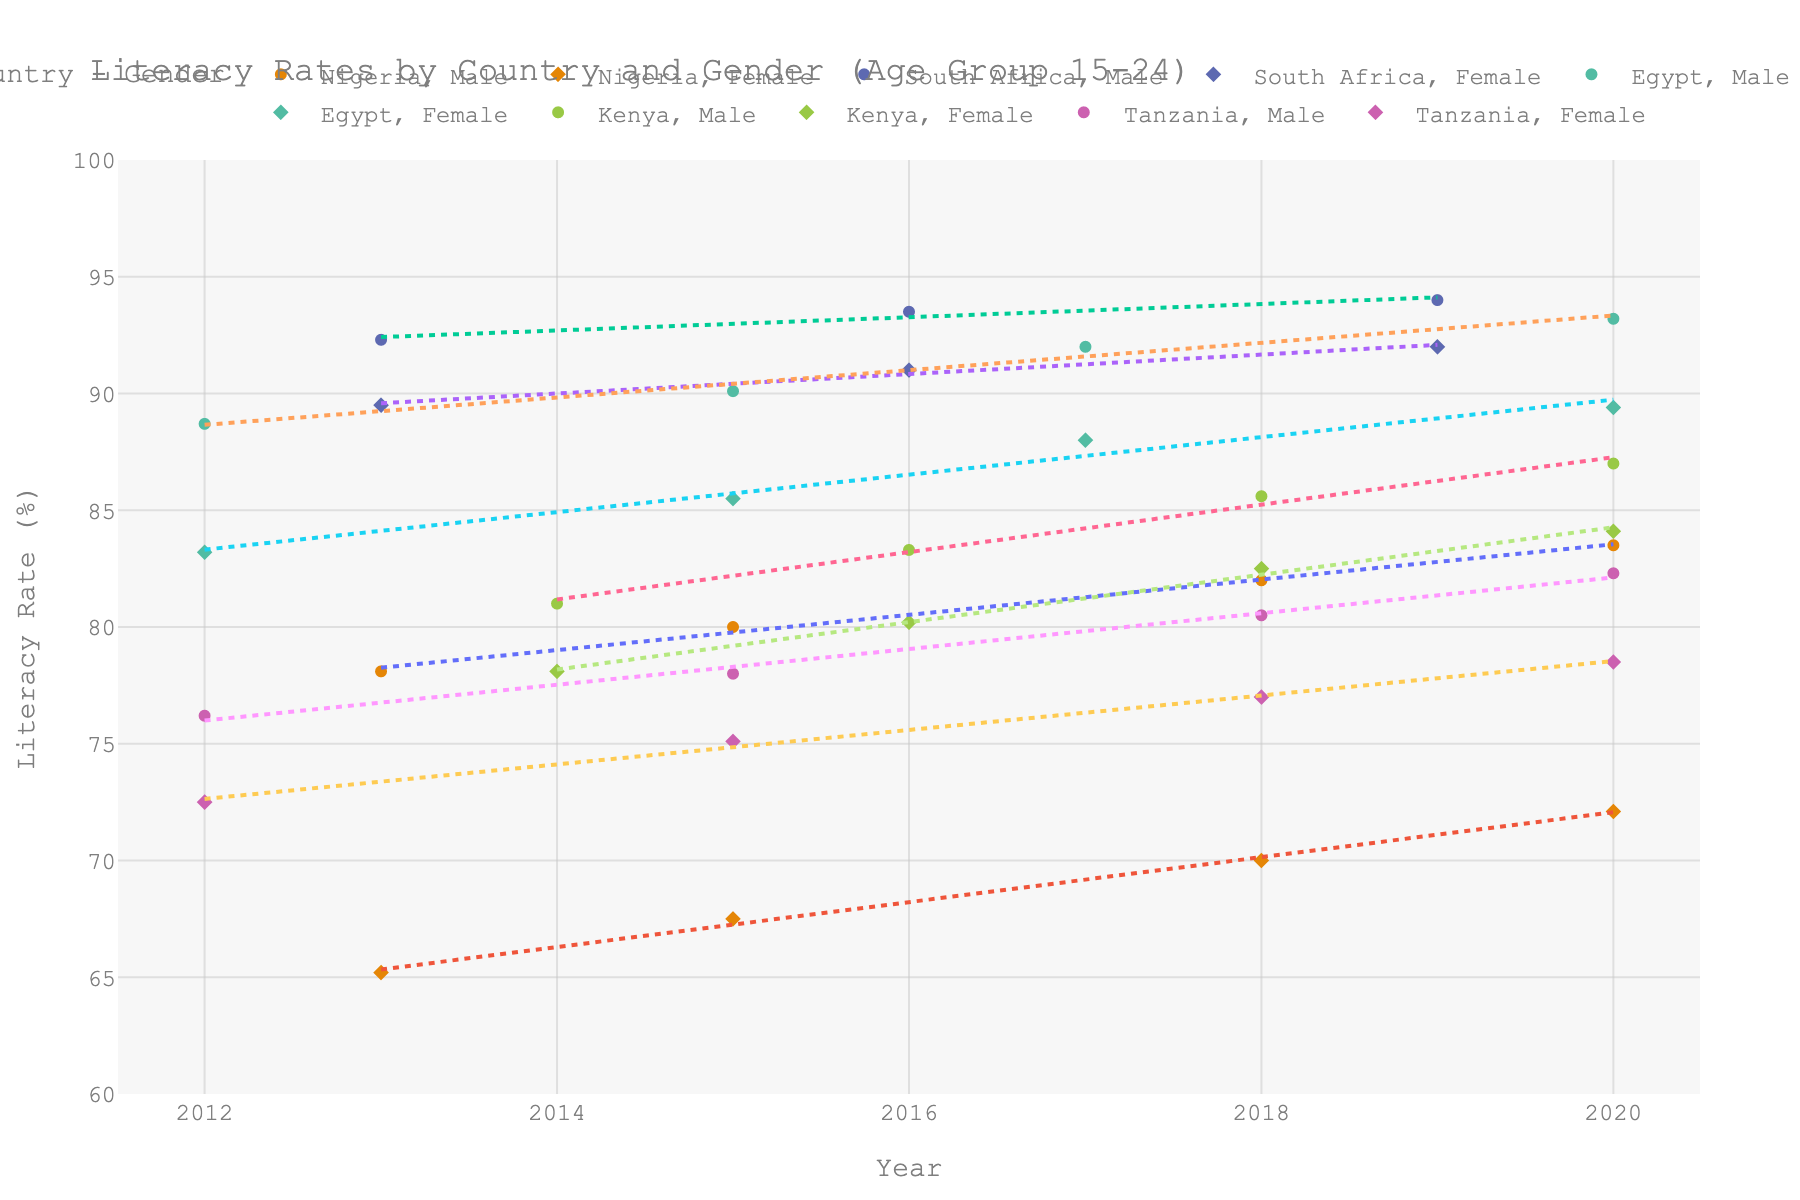What is the title of the figure? The title can typically be found at the top of the figure. Here, it likely summarizes the main theme of the data visualization.
Answer: Literacy Rates by Country and Gender (Age Group 15-24) Which country has the highest male literacy rate overall? To determine this, observe the data points for each country and compare the highest male literacy rates visually.
Answer: South Africa Between 2018 and 2020, did the female literacy rate in Nigeria increase or decrease? Look at the trend line for Nigeria's female literacy rate from 2018 to 2020. Note whether the line slopes upward or downward.
Answer: Increase What is the color used to represent data from Egypt? By looking at the color associated with data points marked as 'Egypt', you can identify the specific color.
Answer: One of the unique colors (likely among the Vivid colors) Does the literacy rate trend line for males in Tanzania show an increasing or decreasing trend? Examine the direction of the trend line for males in Tanzania. If it slopes upward, the trend is increasing; if it slopes downward, decreasing.
Answer: Increasing Compare the literacy rate trend lines for females in Kenya and Nigeria. Which country shows a steeper upward trend? Look at the slopes of the trend lines for female literacy rates in Kenya and Nigeria. The steeper the slope, the greater the rate of change.
Answer: Kenya How does the trend line for males in Egypt compare to that of females over the decade? Observe the general slopes and relative positions of the male and female trend lines for Egypt to determine comparative changes over time.
Answer: Males show a slight increase, while females exhibit a notable rise What was the female literacy rate in Nigeria in 2020? Locate the data point for Nigeria's female literacy rate for the year 2020.
Answer: 72.1% What is the average literacy rate for males in South Africa across the years provided? Locate and sum the literacy rates for South African males for all the given years, then divide by the number of years. (92.3 + 93.5 + 94.0) / 3 = 93.27
Answer: 93.27% Which country shows the smallest gender gap in literacy rates in 2020? Examine the difference between male and female literacy rates for each country in 2020 and identify the smallest gap.
Answer: Egypt Is the literacy rate growth faster for females or males in Kenya from 2014 to 2020? Compare the slope of the trend lines for males and females in Kenya between 2014 and 2020 to see which is steeper.
Answer: Females 